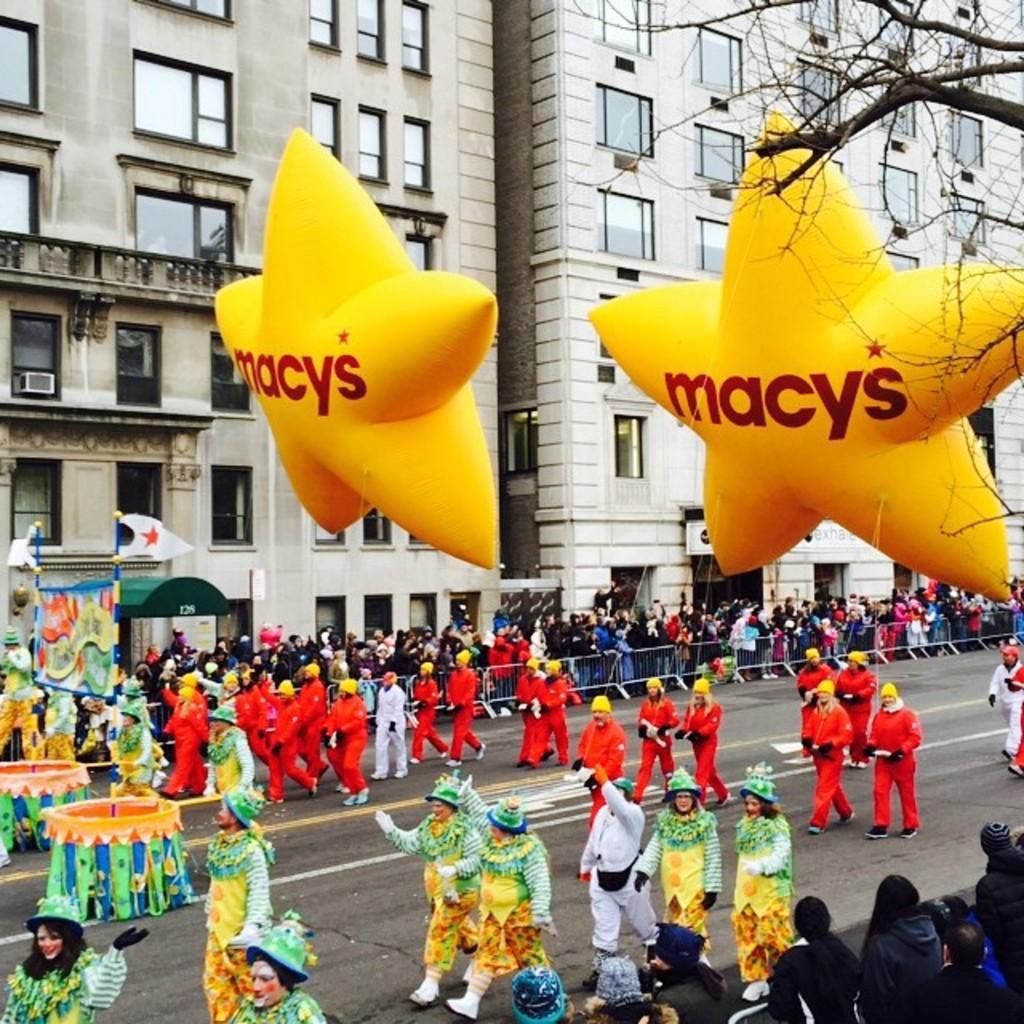In one or two sentences, can you explain what this image depicts? In this image we can see a road. On the road there are many people. Some are wearing caps. On the sides of the road there is a crowd. Some are holding balloons in the shape of star. On the balloons something is written. There are buildings with windows. On the right side we can see branches of a tree. 